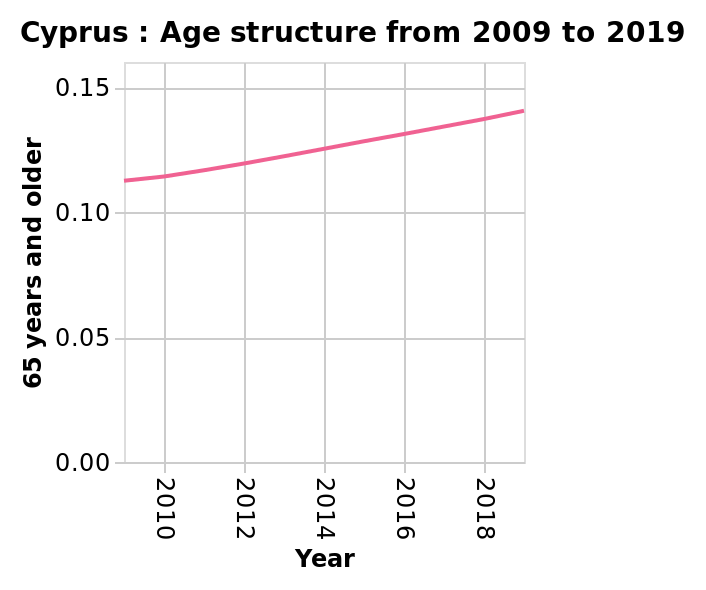<image>
Did the age in Cyprus remain constant from 2009 to 2019?  No, the age in Cyprus did not remain constant, it increased steadily from 2009 to 2019. 